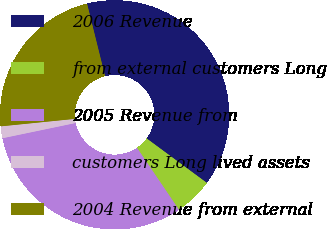<chart> <loc_0><loc_0><loc_500><loc_500><pie_chart><fcel>2006 Revenue<fcel>from external customers Long<fcel>2005 Revenue from<fcel>customers Long lived assets<fcel>2004 Revenue from external<nl><fcel>38.99%<fcel>5.4%<fcel>31.2%<fcel>1.67%<fcel>22.73%<nl></chart> 